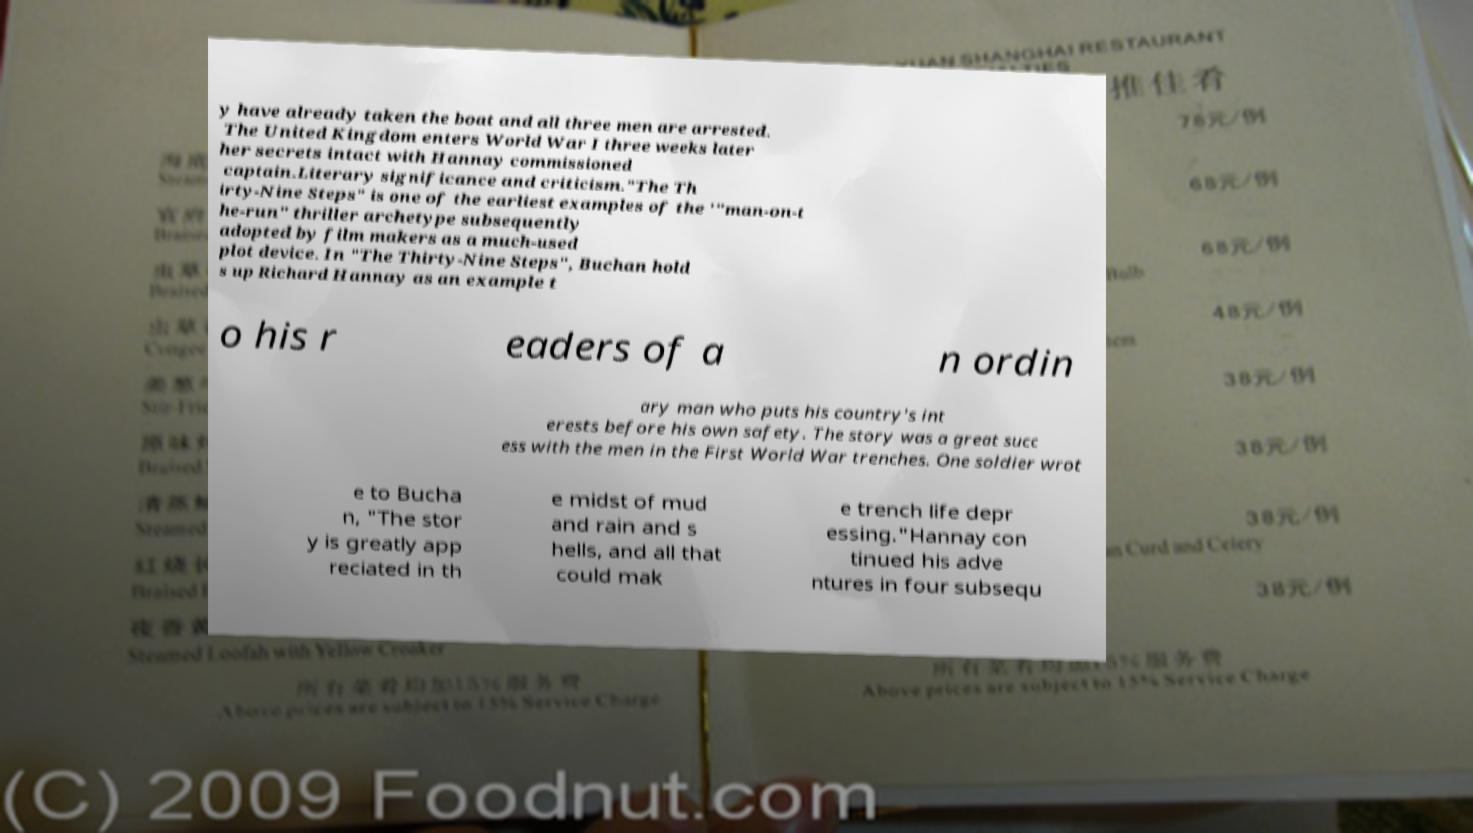Can you accurately transcribe the text from the provided image for me? y have already taken the boat and all three men are arrested. The United Kingdom enters World War I three weeks later her secrets intact with Hannay commissioned captain.Literary significance and criticism."The Th irty-Nine Steps" is one of the earliest examples of the '"man-on-t he-run" thriller archetype subsequently adopted by film makers as a much-used plot device. In "The Thirty-Nine Steps", Buchan hold s up Richard Hannay as an example t o his r eaders of a n ordin ary man who puts his country's int erests before his own safety. The story was a great succ ess with the men in the First World War trenches. One soldier wrot e to Bucha n, "The stor y is greatly app reciated in th e midst of mud and rain and s hells, and all that could mak e trench life depr essing."Hannay con tinued his adve ntures in four subsequ 